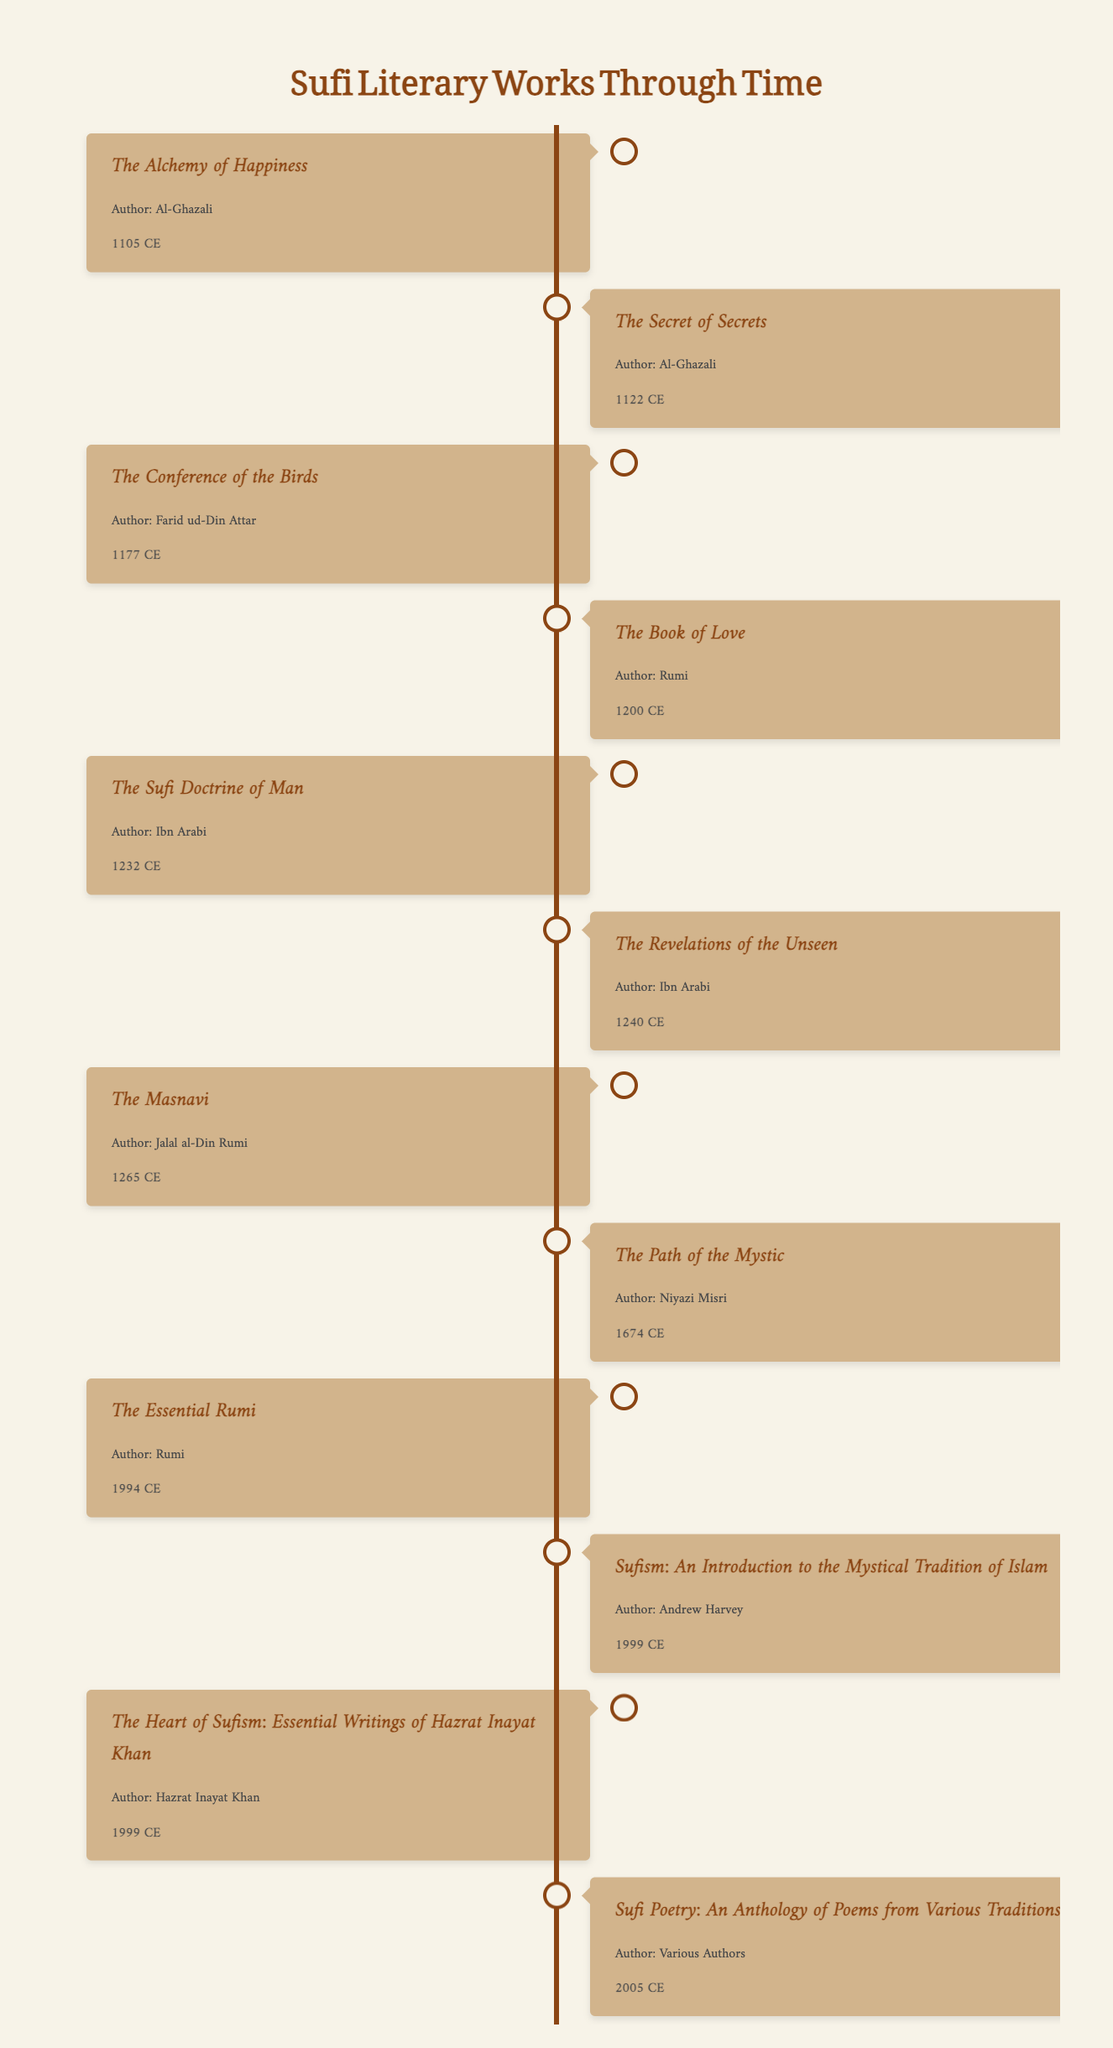What is the title of the work published in 1265? The timeline shows that the work titled "The Masnavi" was published in 1265.
Answer: The Masnavi Who is the author of "The Heart of Sufism"? According to the table, "The Heart of Sufism" was authored by Hazrat Inayat Khan.
Answer: Hazrat Inayat Khan How many works were published before the 13th century? The table lists 6 works published before 1200 (up to 1265): "The Alchemy of Happiness," "The Secret of Secrets," "The Conference of the Birds," "The Book of Love," and "The Sufi Doctrine of Man."
Answer: 6 Is "The Essential Rumi" published before "Sufism: An Introduction to the Mystical Tradition of Islam"? The table indicates "The Essential Rumi" was published in 1994 and "Sufism: An Introduction to the Mystical Tradition of Islam" in 1999, so the statement is false.
Answer: No What is the earliest published work listed? The table shows "The Alchemy of Happiness" published in 1105 as the earliest work.
Answer: The Alchemy of Happiness Which author has multiple works listed? The authors Jalal al-Din Rumi and Al-Ghazali have multiple works listed in the table.
Answer: Jalal al-Din Rumi and Al-Ghazali Calculate the average publication year of the listed works. The sum of the publication years from the works is 1177 + 1265 + 1200 + 1105 + 1122 + 1232 + 1240 + 1674 + 1994 + 1999 + 2005 = 14565. There are 11 works, so the average is 14565 / 11 = 1323.18 (rounded to 1323).
Answer: 1323 What is the total number of works attributed to Ibn Arabi? The table lists two works by Ibn Arabi: "The Sufi Doctrine of Man" (1232) and "The Revelations of the Unseen" (1240). Thus, the total is 2.
Answer: 2 Did any work published after 2000 originate from a single author? The work "Sufi Poetry: An Anthology of Poems from Various Traditions" (2005) is credited to various authors, making it not a single-author work. Thus, the answer is false.
Answer: No Which work was published closest to the year 2000? The table indicates "The Essential Rumi" published in 1994 and "Sufism: An Introduction to the Mystical Tradition of Islam" in 1999 as closest to 2000, with "The Heart of Sufism" also in the same year.
Answer: The Heart of Sufism and Sufism: An Introduction to the Mystical Tradition of Islam (both in 1999) 